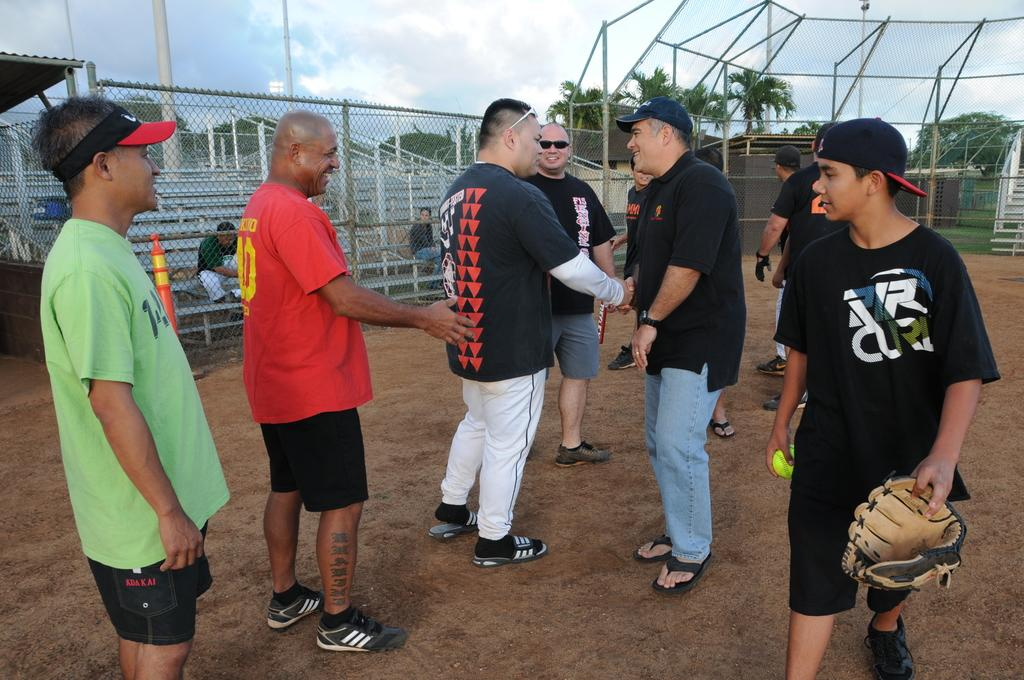<image>
Provide a brief description of the given image. a boy at a field with others and the letter R on his shirt 